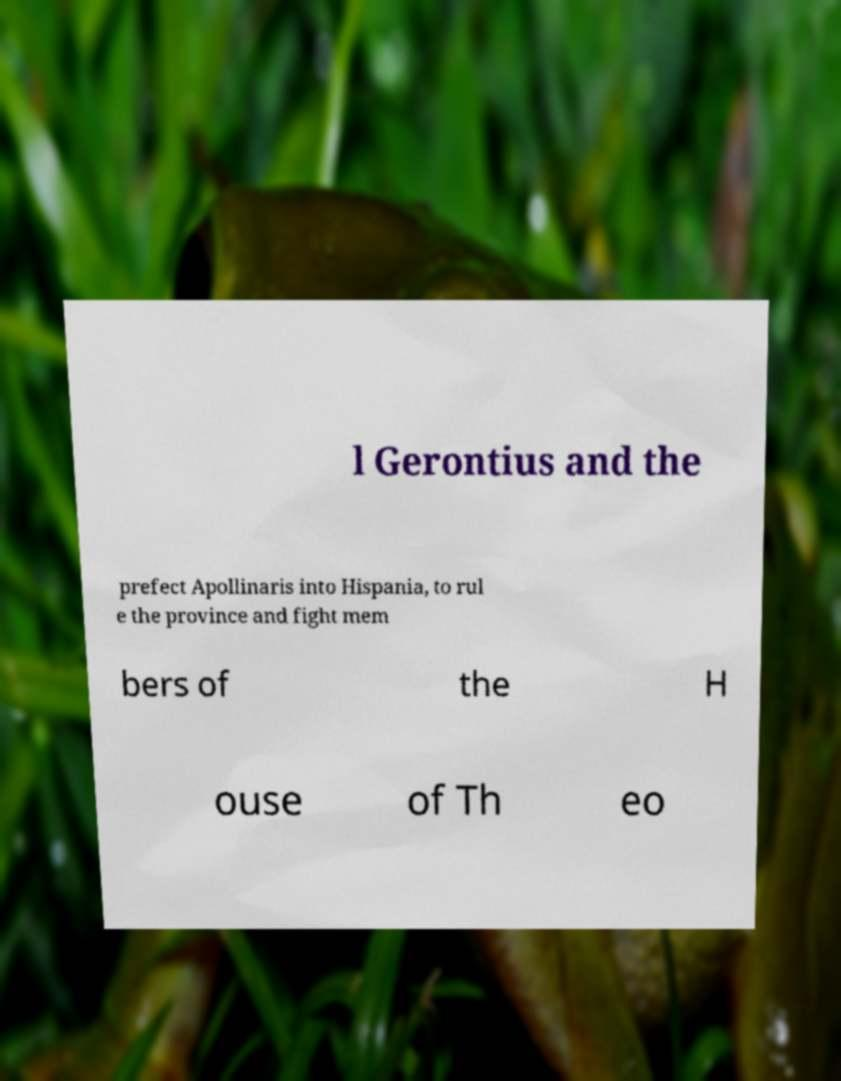Please identify and transcribe the text found in this image. l Gerontius and the prefect Apollinaris into Hispania, to rul e the province and fight mem bers of the H ouse of Th eo 